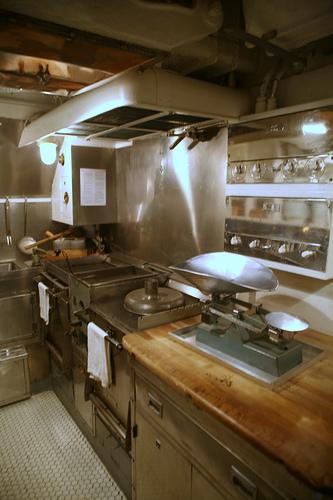What type of wooden utensil do you see?
Concise answer only. Spoon. What are the towels hanging from?
Give a very brief answer. Oven handles. Is this a kitchen?
Give a very brief answer. Yes. What kind of scale is that?
Write a very short answer. Food scale. 